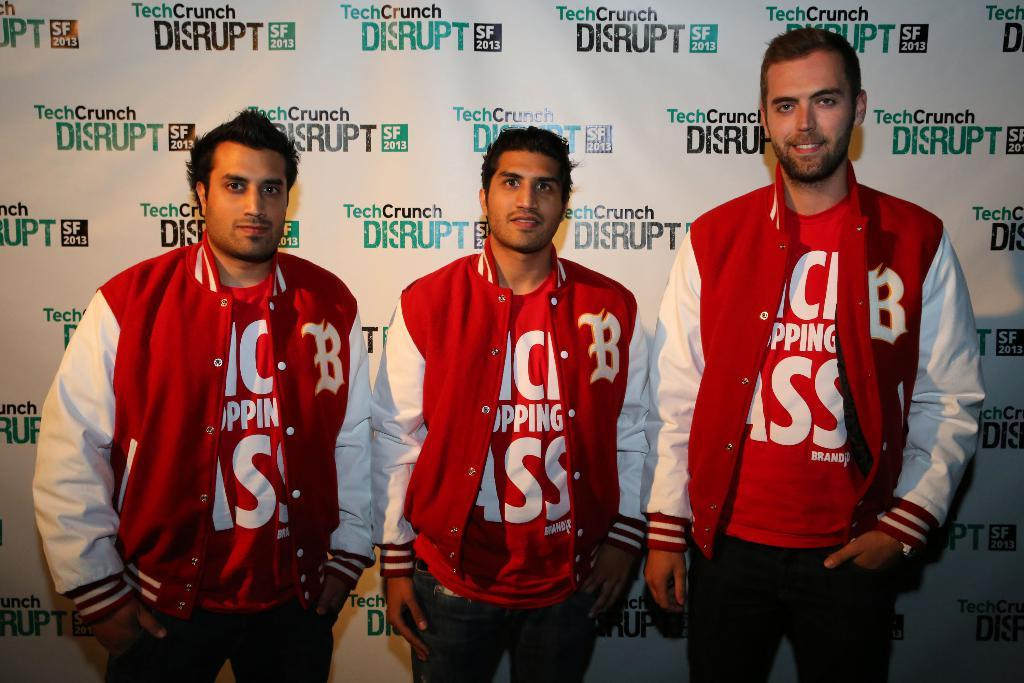How many men are in the image? There are three men in the image. What are the men wearing? The men are wearing the same dresses. What are the men doing in the image? The men are standing and giving a pose for the picture. What is the facial expression of the men? The men are smiling. What can be seen in the background of the image? There is a board in the background of the image. What is written on the board? There is text on the board. What type of hose is being used by the men in the image? There is no hose present in the image. What vegetables are being held by the men in the image? There are no vegetables present in the image. 